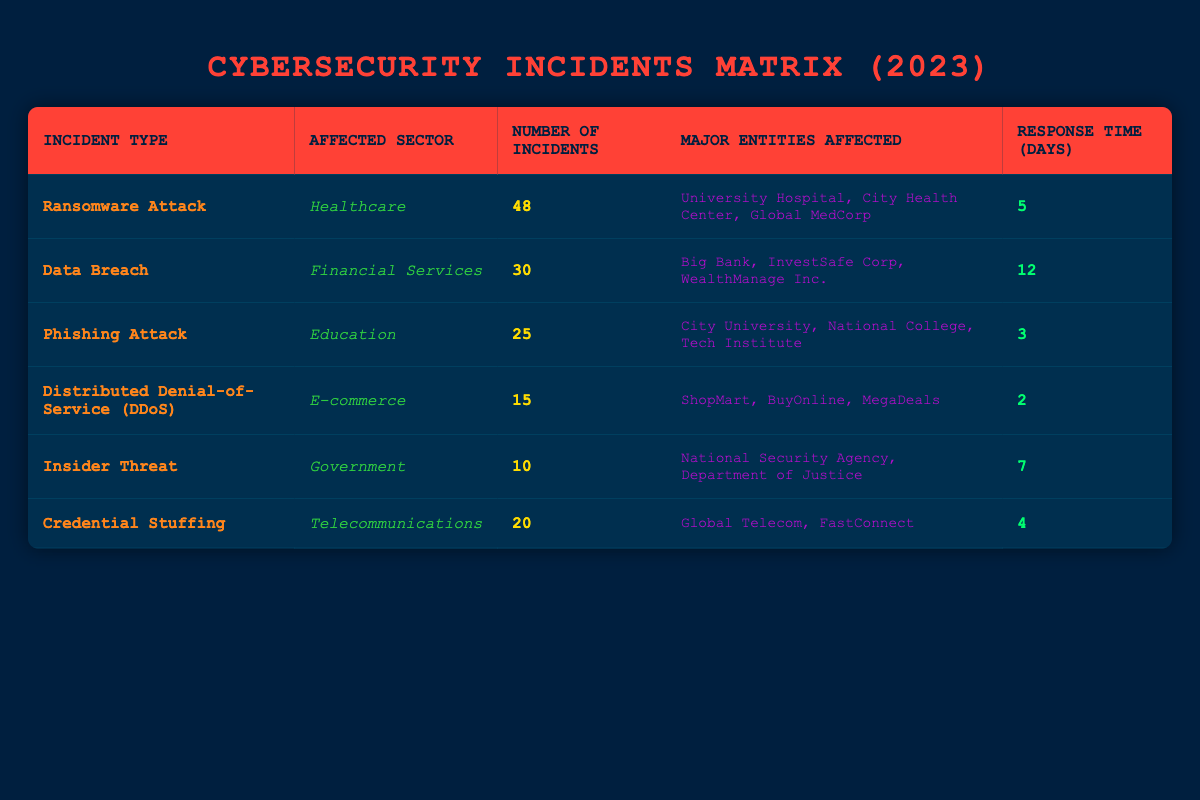What is the most common incident type reported in 2023? The most common incident type can be found by identifying the incident type with the highest number of incidents listed in the table. The Ransomware Attack has the highest number at 48.
Answer: Ransomware Attack Which sector experienced the least number of cybersecurity incidents? Looking at the "Number of Incidents" column, the sector with the smallest number is Government, which only had 10 incidents from Insider Threats.
Answer: Government What is the average response time for all incident types? To find the average response time, first sum the response times: (5 + 12 + 3 + 2 + 7 + 4) = 33 days. There are 6 incident types, so we calculate the average as 33/6 = 5.5 days.
Answer: 5.5 Did the E-commerce sector have more incidents than the Education sector? From the table, E-commerce had 15 incidents (DDoS) while Education had 25 incidents (Phishing Attack). Since 15 is less than 25, the E-commerce sector did not have more incidents.
Answer: No How many incidents were reported in the Financial Services and Telecommunications sectors combined? To find the total, we add the incidents from both sectors: 30 (Financial Services) + 20 (Telecommunications) = 50 incidents combined.
Answer: 50 Are Ransomware Attacks more frequent than Credential Stuffing incidents? The number of Ransomware Attack incidents is 48, while Credential Stuffing incidents number 20. Since 48 is greater than 20, we conclude that Ransomware Attacks are indeed more frequent.
Answer: Yes What is the difference in the number of incidents between the Healthcare and Government sectors? In the Healthcare sector, there were 48 incidents, while in the Government sector, there were 10. The difference is calculated as 48 - 10 = 38.
Answer: 38 List one major entity affected by Phishing Attacks. Referring to the table under Phishing Attacks in the Education sector, one of the major entities affected is City University.
Answer: City University 